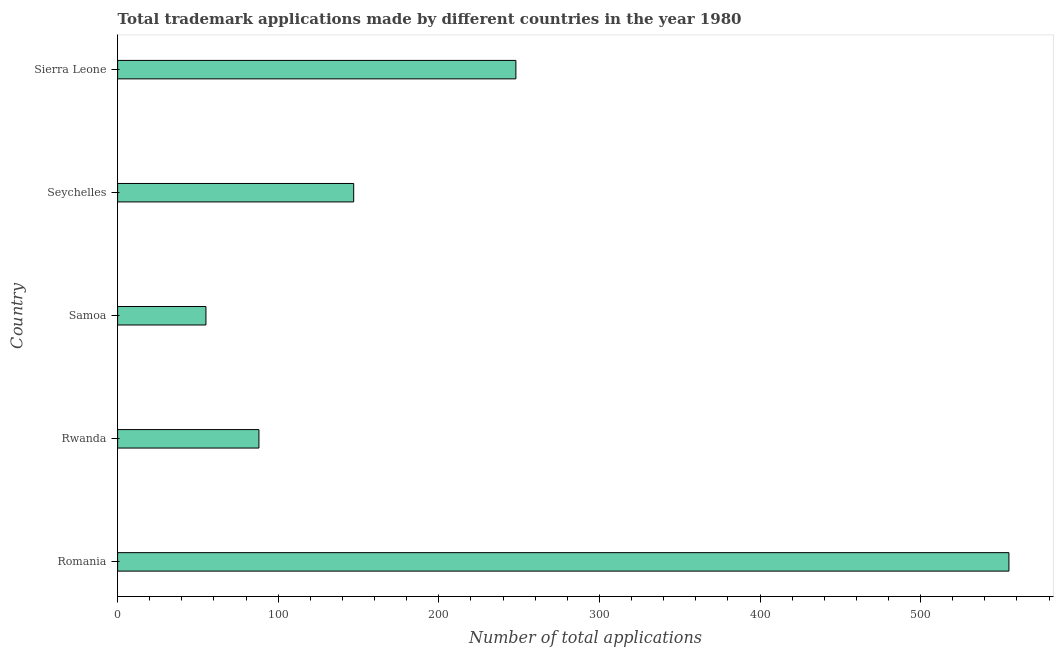Does the graph contain any zero values?
Provide a short and direct response. No. What is the title of the graph?
Keep it short and to the point. Total trademark applications made by different countries in the year 1980. What is the label or title of the X-axis?
Keep it short and to the point. Number of total applications. What is the number of trademark applications in Seychelles?
Make the answer very short. 147. Across all countries, what is the maximum number of trademark applications?
Make the answer very short. 555. Across all countries, what is the minimum number of trademark applications?
Your answer should be very brief. 55. In which country was the number of trademark applications maximum?
Offer a very short reply. Romania. In which country was the number of trademark applications minimum?
Keep it short and to the point. Samoa. What is the sum of the number of trademark applications?
Your answer should be very brief. 1093. What is the average number of trademark applications per country?
Your response must be concise. 218. What is the median number of trademark applications?
Your answer should be compact. 147. In how many countries, is the number of trademark applications greater than 480 ?
Keep it short and to the point. 1. What is the ratio of the number of trademark applications in Samoa to that in Sierra Leone?
Give a very brief answer. 0.22. What is the difference between the highest and the second highest number of trademark applications?
Provide a short and direct response. 307. What is the difference between the highest and the lowest number of trademark applications?
Offer a very short reply. 500. Are all the bars in the graph horizontal?
Provide a short and direct response. Yes. What is the difference between two consecutive major ticks on the X-axis?
Offer a very short reply. 100. What is the Number of total applications in Romania?
Provide a short and direct response. 555. What is the Number of total applications in Samoa?
Make the answer very short. 55. What is the Number of total applications of Seychelles?
Your answer should be very brief. 147. What is the Number of total applications in Sierra Leone?
Give a very brief answer. 248. What is the difference between the Number of total applications in Romania and Rwanda?
Provide a succinct answer. 467. What is the difference between the Number of total applications in Romania and Samoa?
Offer a terse response. 500. What is the difference between the Number of total applications in Romania and Seychelles?
Offer a very short reply. 408. What is the difference between the Number of total applications in Romania and Sierra Leone?
Ensure brevity in your answer.  307. What is the difference between the Number of total applications in Rwanda and Samoa?
Offer a very short reply. 33. What is the difference between the Number of total applications in Rwanda and Seychelles?
Keep it short and to the point. -59. What is the difference between the Number of total applications in Rwanda and Sierra Leone?
Keep it short and to the point. -160. What is the difference between the Number of total applications in Samoa and Seychelles?
Ensure brevity in your answer.  -92. What is the difference between the Number of total applications in Samoa and Sierra Leone?
Keep it short and to the point. -193. What is the difference between the Number of total applications in Seychelles and Sierra Leone?
Your answer should be very brief. -101. What is the ratio of the Number of total applications in Romania to that in Rwanda?
Provide a succinct answer. 6.31. What is the ratio of the Number of total applications in Romania to that in Samoa?
Make the answer very short. 10.09. What is the ratio of the Number of total applications in Romania to that in Seychelles?
Provide a short and direct response. 3.78. What is the ratio of the Number of total applications in Romania to that in Sierra Leone?
Ensure brevity in your answer.  2.24. What is the ratio of the Number of total applications in Rwanda to that in Samoa?
Ensure brevity in your answer.  1.6. What is the ratio of the Number of total applications in Rwanda to that in Seychelles?
Keep it short and to the point. 0.6. What is the ratio of the Number of total applications in Rwanda to that in Sierra Leone?
Make the answer very short. 0.35. What is the ratio of the Number of total applications in Samoa to that in Seychelles?
Give a very brief answer. 0.37. What is the ratio of the Number of total applications in Samoa to that in Sierra Leone?
Keep it short and to the point. 0.22. What is the ratio of the Number of total applications in Seychelles to that in Sierra Leone?
Give a very brief answer. 0.59. 